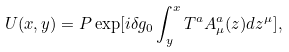<formula> <loc_0><loc_0><loc_500><loc_500>U ( x , y ) = P \exp [ i \delta g _ { 0 } \int _ { y } ^ { x } T ^ { a } A _ { \mu } ^ { a } ( z ) d z ^ { \mu } ] ,</formula> 